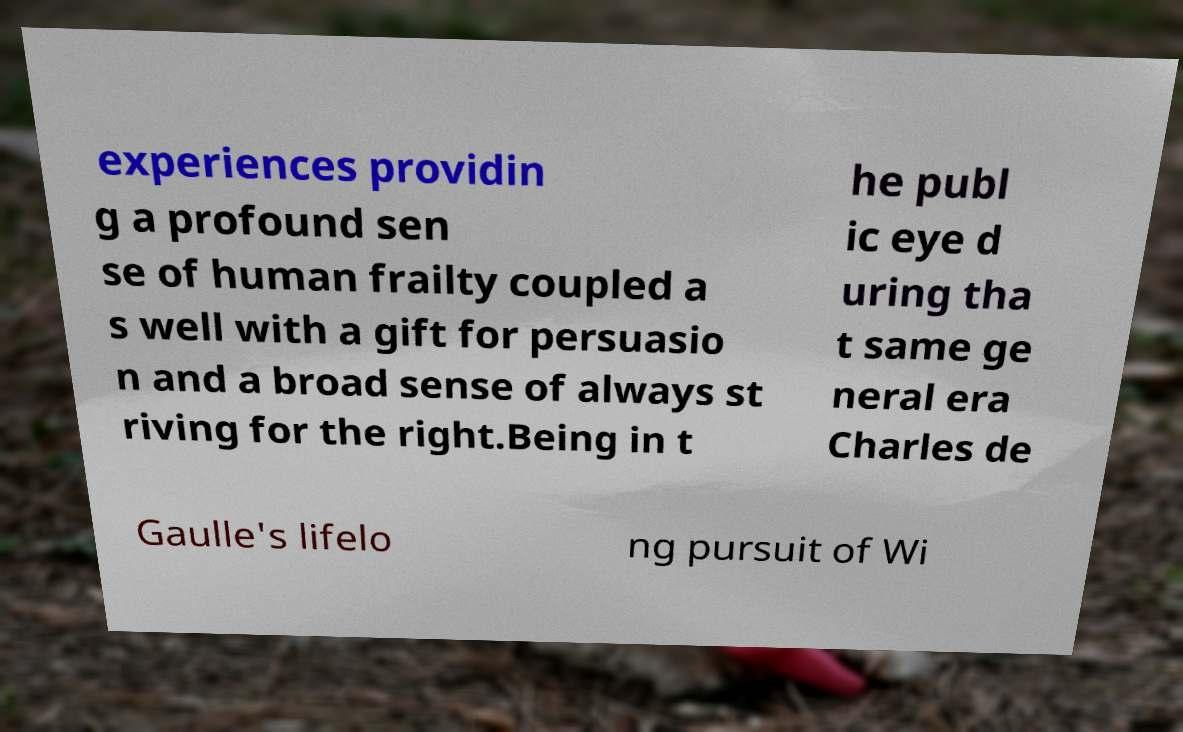Please identify and transcribe the text found in this image. experiences providin g a profound sen se of human frailty coupled a s well with a gift for persuasio n and a broad sense of always st riving for the right.Being in t he publ ic eye d uring tha t same ge neral era Charles de Gaulle's lifelo ng pursuit of Wi 